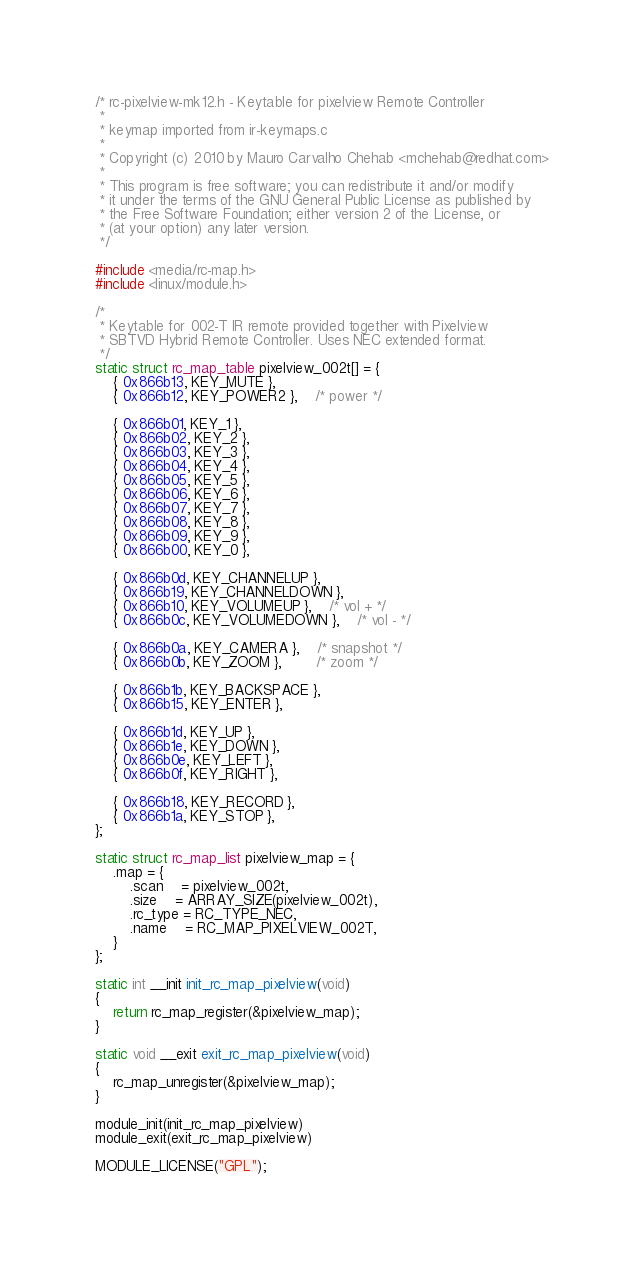<code> <loc_0><loc_0><loc_500><loc_500><_C_>/* rc-pixelview-mk12.h - Keytable for pixelview Remote Controller
 *
 * keymap imported from ir-keymaps.c
 *
 * Copyright (c) 2010 by Mauro Carvalho Chehab <mchehab@redhat.com>
 *
 * This program is free software; you can redistribute it and/or modify
 * it under the terms of the GNU General Public License as published by
 * the Free Software Foundation; either version 2 of the License, or
 * (at your option) any later version.
 */

#include <media/rc-map.h>
#include <linux/module.h>

/*
 * Keytable for 002-T IR remote provided together with Pixelview
 * SBTVD Hybrid Remote Controller. Uses NEC extended format.
 */
static struct rc_map_table pixelview_002t[] = {
	{ 0x866b13, KEY_MUTE },
	{ 0x866b12, KEY_POWER2 },	/* power */

	{ 0x866b01, KEY_1 },
	{ 0x866b02, KEY_2 },
	{ 0x866b03, KEY_3 },
	{ 0x866b04, KEY_4 },
	{ 0x866b05, KEY_5 },
	{ 0x866b06, KEY_6 },
	{ 0x866b07, KEY_7 },
	{ 0x866b08, KEY_8 },
	{ 0x866b09, KEY_9 },
	{ 0x866b00, KEY_0 },

	{ 0x866b0d, KEY_CHANNELUP },
	{ 0x866b19, KEY_CHANNELDOWN },
	{ 0x866b10, KEY_VOLUMEUP },	/* vol + */
	{ 0x866b0c, KEY_VOLUMEDOWN },	/* vol - */

	{ 0x866b0a, KEY_CAMERA },	/* snapshot */
	{ 0x866b0b, KEY_ZOOM },		/* zoom */

	{ 0x866b1b, KEY_BACKSPACE },
	{ 0x866b15, KEY_ENTER },

	{ 0x866b1d, KEY_UP },
	{ 0x866b1e, KEY_DOWN },
	{ 0x866b0e, KEY_LEFT },
	{ 0x866b0f, KEY_RIGHT },

	{ 0x866b18, KEY_RECORD },
	{ 0x866b1a, KEY_STOP },
};

static struct rc_map_list pixelview_map = {
	.map = {
		.scan    = pixelview_002t,
		.size    = ARRAY_SIZE(pixelview_002t),
		.rc_type = RC_TYPE_NEC,
		.name    = RC_MAP_PIXELVIEW_002T,
	}
};

static int __init init_rc_map_pixelview(void)
{
	return rc_map_register(&pixelview_map);
}

static void __exit exit_rc_map_pixelview(void)
{
	rc_map_unregister(&pixelview_map);
}

module_init(init_rc_map_pixelview)
module_exit(exit_rc_map_pixelview)

MODULE_LICENSE("GPL");</code> 